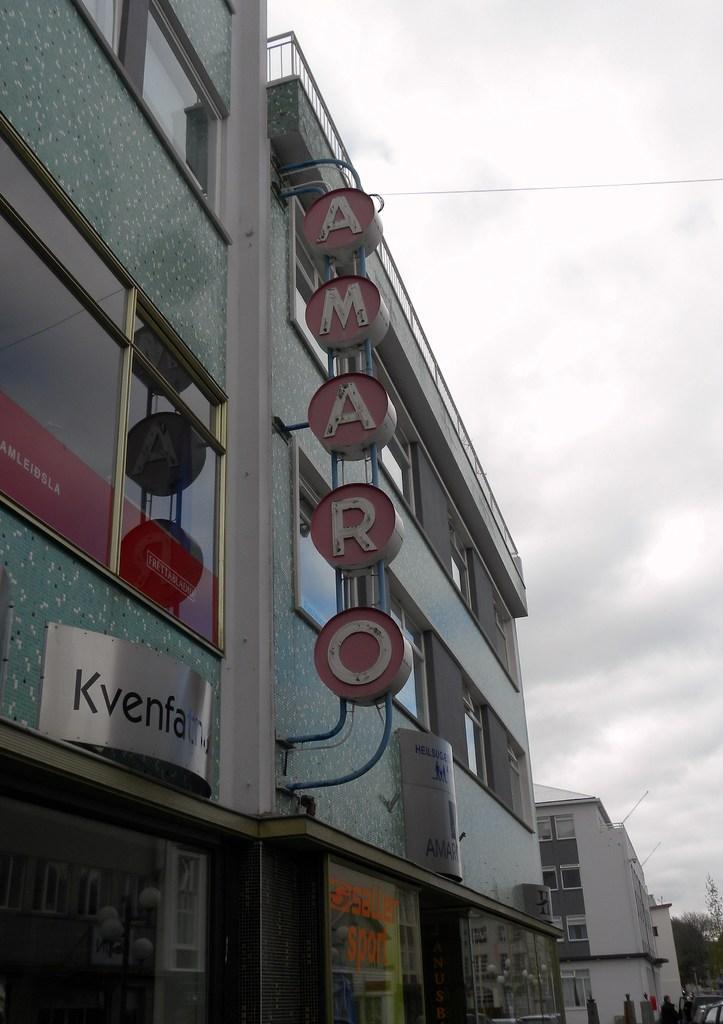Describe this image in one or two sentences. In this image we can see building, name boards, persons on the road, trees and sky with clouds. 